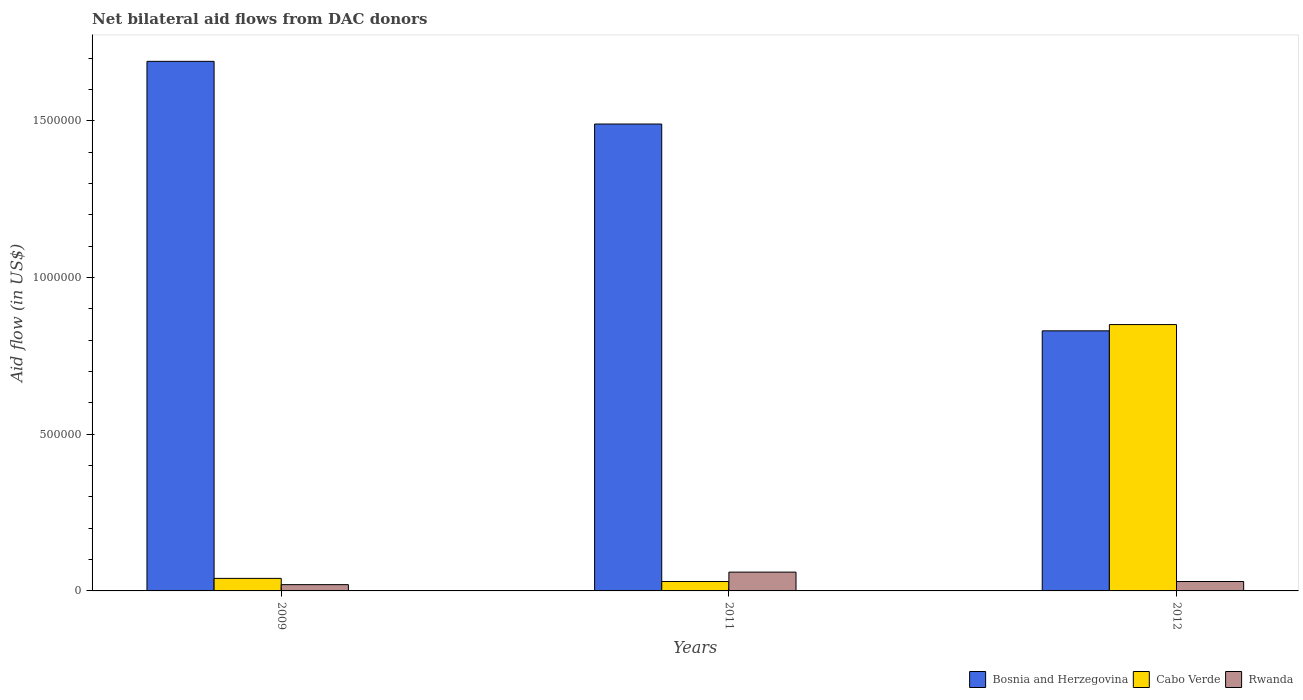How many different coloured bars are there?
Provide a short and direct response. 3. How many groups of bars are there?
Make the answer very short. 3. Are the number of bars on each tick of the X-axis equal?
Make the answer very short. Yes. How many bars are there on the 1st tick from the left?
Your answer should be compact. 3. How many bars are there on the 2nd tick from the right?
Your answer should be compact. 3. What is the net bilateral aid flow in Rwanda in 2009?
Give a very brief answer. 2.00e+04. Across all years, what is the maximum net bilateral aid flow in Cabo Verde?
Your answer should be very brief. 8.50e+05. Across all years, what is the minimum net bilateral aid flow in Rwanda?
Provide a short and direct response. 2.00e+04. In which year was the net bilateral aid flow in Bosnia and Herzegovina maximum?
Offer a terse response. 2009. In which year was the net bilateral aid flow in Bosnia and Herzegovina minimum?
Make the answer very short. 2012. What is the total net bilateral aid flow in Cabo Verde in the graph?
Give a very brief answer. 9.20e+05. What is the difference between the net bilateral aid flow in Rwanda in 2009 and that in 2012?
Your response must be concise. -10000. What is the difference between the net bilateral aid flow in Cabo Verde in 2011 and the net bilateral aid flow in Bosnia and Herzegovina in 2009?
Keep it short and to the point. -1.66e+06. What is the average net bilateral aid flow in Cabo Verde per year?
Give a very brief answer. 3.07e+05. In the year 2011, what is the difference between the net bilateral aid flow in Bosnia and Herzegovina and net bilateral aid flow in Rwanda?
Your answer should be compact. 1.43e+06. In how many years, is the net bilateral aid flow in Rwanda greater than 600000 US$?
Offer a terse response. 0. Is the net bilateral aid flow in Rwanda in 2009 less than that in 2011?
Provide a succinct answer. Yes. Is the difference between the net bilateral aid flow in Bosnia and Herzegovina in 2011 and 2012 greater than the difference between the net bilateral aid flow in Rwanda in 2011 and 2012?
Your response must be concise. Yes. What is the difference between the highest and the second highest net bilateral aid flow in Rwanda?
Provide a short and direct response. 3.00e+04. What is the difference between the highest and the lowest net bilateral aid flow in Cabo Verde?
Make the answer very short. 8.20e+05. What does the 3rd bar from the left in 2011 represents?
Keep it short and to the point. Rwanda. What does the 2nd bar from the right in 2012 represents?
Provide a succinct answer. Cabo Verde. How many bars are there?
Make the answer very short. 9. How many years are there in the graph?
Keep it short and to the point. 3. What is the difference between two consecutive major ticks on the Y-axis?
Give a very brief answer. 5.00e+05. Does the graph contain any zero values?
Ensure brevity in your answer.  No. Does the graph contain grids?
Offer a very short reply. No. Where does the legend appear in the graph?
Give a very brief answer. Bottom right. What is the title of the graph?
Your response must be concise. Net bilateral aid flows from DAC donors. Does "Ghana" appear as one of the legend labels in the graph?
Give a very brief answer. No. What is the label or title of the Y-axis?
Keep it short and to the point. Aid flow (in US$). What is the Aid flow (in US$) of Bosnia and Herzegovina in 2009?
Offer a terse response. 1.69e+06. What is the Aid flow (in US$) of Cabo Verde in 2009?
Give a very brief answer. 4.00e+04. What is the Aid flow (in US$) of Rwanda in 2009?
Make the answer very short. 2.00e+04. What is the Aid flow (in US$) in Bosnia and Herzegovina in 2011?
Provide a short and direct response. 1.49e+06. What is the Aid flow (in US$) of Bosnia and Herzegovina in 2012?
Your answer should be compact. 8.30e+05. What is the Aid flow (in US$) in Cabo Verde in 2012?
Ensure brevity in your answer.  8.50e+05. Across all years, what is the maximum Aid flow (in US$) in Bosnia and Herzegovina?
Give a very brief answer. 1.69e+06. Across all years, what is the maximum Aid flow (in US$) of Cabo Verde?
Ensure brevity in your answer.  8.50e+05. Across all years, what is the minimum Aid flow (in US$) of Bosnia and Herzegovina?
Your answer should be compact. 8.30e+05. Across all years, what is the minimum Aid flow (in US$) in Cabo Verde?
Provide a succinct answer. 3.00e+04. Across all years, what is the minimum Aid flow (in US$) of Rwanda?
Offer a very short reply. 2.00e+04. What is the total Aid flow (in US$) in Bosnia and Herzegovina in the graph?
Keep it short and to the point. 4.01e+06. What is the total Aid flow (in US$) in Cabo Verde in the graph?
Your answer should be compact. 9.20e+05. What is the difference between the Aid flow (in US$) of Bosnia and Herzegovina in 2009 and that in 2011?
Ensure brevity in your answer.  2.00e+05. What is the difference between the Aid flow (in US$) in Bosnia and Herzegovina in 2009 and that in 2012?
Keep it short and to the point. 8.60e+05. What is the difference between the Aid flow (in US$) of Cabo Verde in 2009 and that in 2012?
Offer a terse response. -8.10e+05. What is the difference between the Aid flow (in US$) in Cabo Verde in 2011 and that in 2012?
Ensure brevity in your answer.  -8.20e+05. What is the difference between the Aid flow (in US$) in Bosnia and Herzegovina in 2009 and the Aid flow (in US$) in Cabo Verde in 2011?
Provide a short and direct response. 1.66e+06. What is the difference between the Aid flow (in US$) in Bosnia and Herzegovina in 2009 and the Aid flow (in US$) in Rwanda in 2011?
Offer a terse response. 1.63e+06. What is the difference between the Aid flow (in US$) of Bosnia and Herzegovina in 2009 and the Aid flow (in US$) of Cabo Verde in 2012?
Provide a succinct answer. 8.40e+05. What is the difference between the Aid flow (in US$) in Bosnia and Herzegovina in 2009 and the Aid flow (in US$) in Rwanda in 2012?
Make the answer very short. 1.66e+06. What is the difference between the Aid flow (in US$) of Bosnia and Herzegovina in 2011 and the Aid flow (in US$) of Cabo Verde in 2012?
Keep it short and to the point. 6.40e+05. What is the difference between the Aid flow (in US$) in Bosnia and Herzegovina in 2011 and the Aid flow (in US$) in Rwanda in 2012?
Offer a terse response. 1.46e+06. What is the difference between the Aid flow (in US$) of Cabo Verde in 2011 and the Aid flow (in US$) of Rwanda in 2012?
Your answer should be compact. 0. What is the average Aid flow (in US$) in Bosnia and Herzegovina per year?
Make the answer very short. 1.34e+06. What is the average Aid flow (in US$) of Cabo Verde per year?
Your answer should be very brief. 3.07e+05. What is the average Aid flow (in US$) of Rwanda per year?
Give a very brief answer. 3.67e+04. In the year 2009, what is the difference between the Aid flow (in US$) in Bosnia and Herzegovina and Aid flow (in US$) in Cabo Verde?
Offer a terse response. 1.65e+06. In the year 2009, what is the difference between the Aid flow (in US$) in Bosnia and Herzegovina and Aid flow (in US$) in Rwanda?
Your response must be concise. 1.67e+06. In the year 2009, what is the difference between the Aid flow (in US$) in Cabo Verde and Aid flow (in US$) in Rwanda?
Offer a terse response. 2.00e+04. In the year 2011, what is the difference between the Aid flow (in US$) in Bosnia and Herzegovina and Aid flow (in US$) in Cabo Verde?
Give a very brief answer. 1.46e+06. In the year 2011, what is the difference between the Aid flow (in US$) in Bosnia and Herzegovina and Aid flow (in US$) in Rwanda?
Make the answer very short. 1.43e+06. In the year 2012, what is the difference between the Aid flow (in US$) of Bosnia and Herzegovina and Aid flow (in US$) of Cabo Verde?
Offer a very short reply. -2.00e+04. In the year 2012, what is the difference between the Aid flow (in US$) in Bosnia and Herzegovina and Aid flow (in US$) in Rwanda?
Offer a very short reply. 8.00e+05. In the year 2012, what is the difference between the Aid flow (in US$) in Cabo Verde and Aid flow (in US$) in Rwanda?
Your answer should be very brief. 8.20e+05. What is the ratio of the Aid flow (in US$) of Bosnia and Herzegovina in 2009 to that in 2011?
Provide a short and direct response. 1.13. What is the ratio of the Aid flow (in US$) of Cabo Verde in 2009 to that in 2011?
Offer a very short reply. 1.33. What is the ratio of the Aid flow (in US$) in Bosnia and Herzegovina in 2009 to that in 2012?
Your response must be concise. 2.04. What is the ratio of the Aid flow (in US$) in Cabo Verde in 2009 to that in 2012?
Provide a short and direct response. 0.05. What is the ratio of the Aid flow (in US$) in Bosnia and Herzegovina in 2011 to that in 2012?
Give a very brief answer. 1.8. What is the ratio of the Aid flow (in US$) in Cabo Verde in 2011 to that in 2012?
Your response must be concise. 0.04. What is the difference between the highest and the second highest Aid flow (in US$) in Cabo Verde?
Your answer should be compact. 8.10e+05. What is the difference between the highest and the second highest Aid flow (in US$) in Rwanda?
Your answer should be very brief. 3.00e+04. What is the difference between the highest and the lowest Aid flow (in US$) in Bosnia and Herzegovina?
Provide a succinct answer. 8.60e+05. What is the difference between the highest and the lowest Aid flow (in US$) of Cabo Verde?
Make the answer very short. 8.20e+05. 